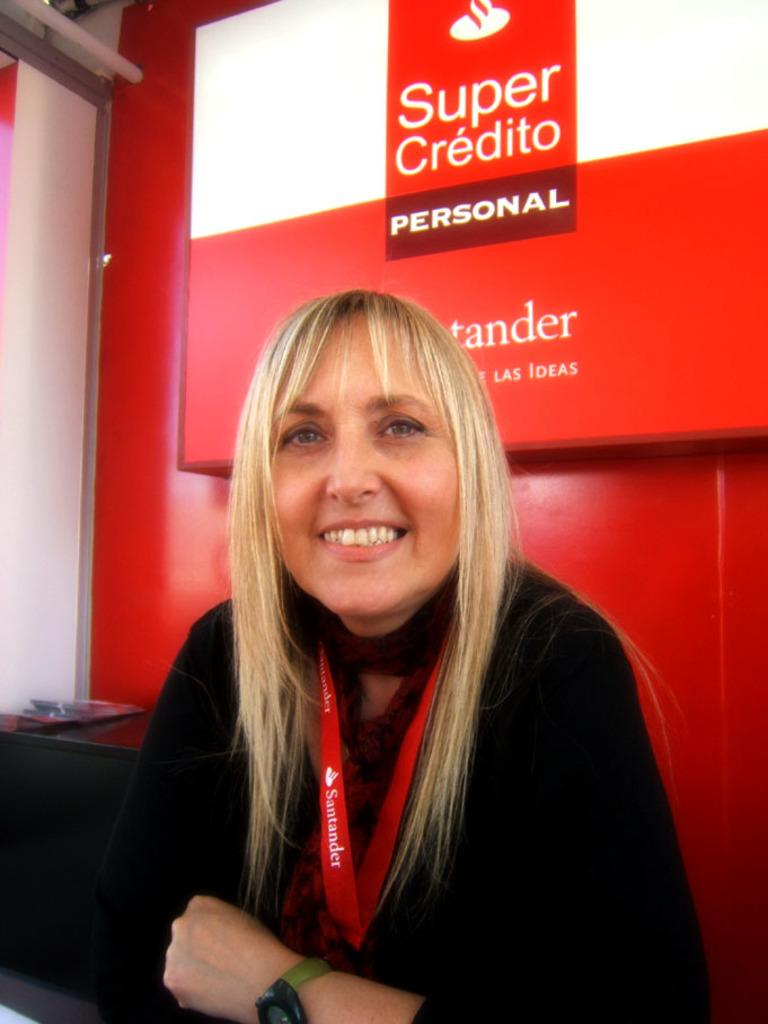Who is present in the image? There is a woman in the image. What is the woman wearing? The woman is wearing a black dress. Does the woman have any identification in the image? Yes, the woman has an ID card. What can be seen in the background of the image? There is a screen with text in the background of the image. Can you see any fairies flying around the woman in the image? No, there are no fairies present in the image. What type of soda is the woman holding in the image? There is no soda visible in the image. 